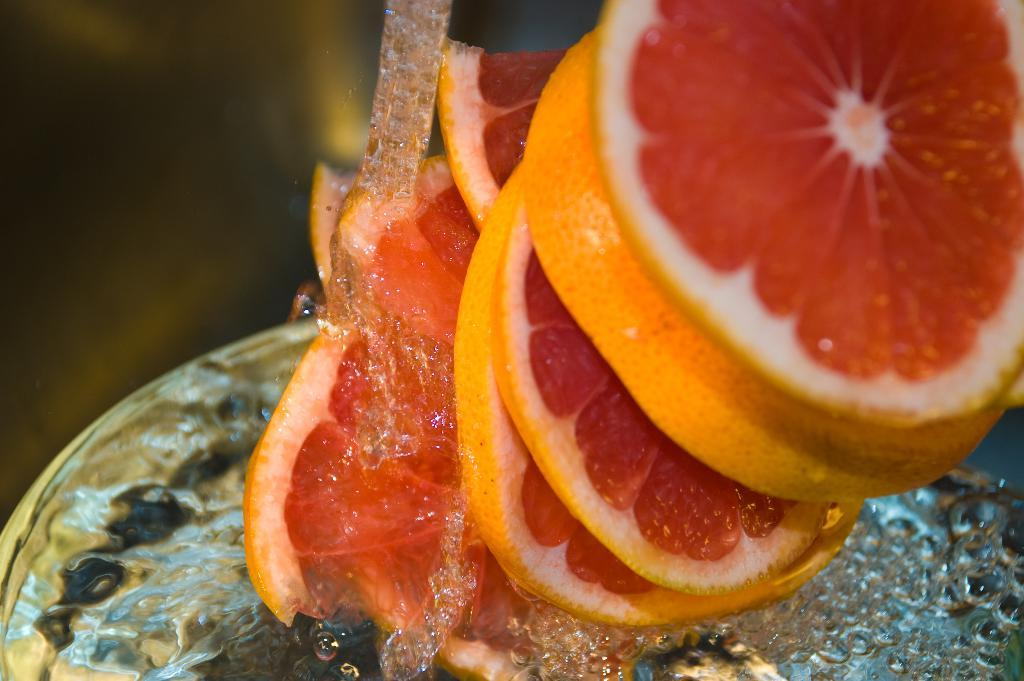What type of fruit can be seen in the image? There are slices of orange in the image. What else is visible in the image besides the orange slices? There is water visible in the image. Can you describe the water in the image? The water has bubbles. What color of paint is being used to express anger in the image? There is no paint or expression of anger present in the image. 